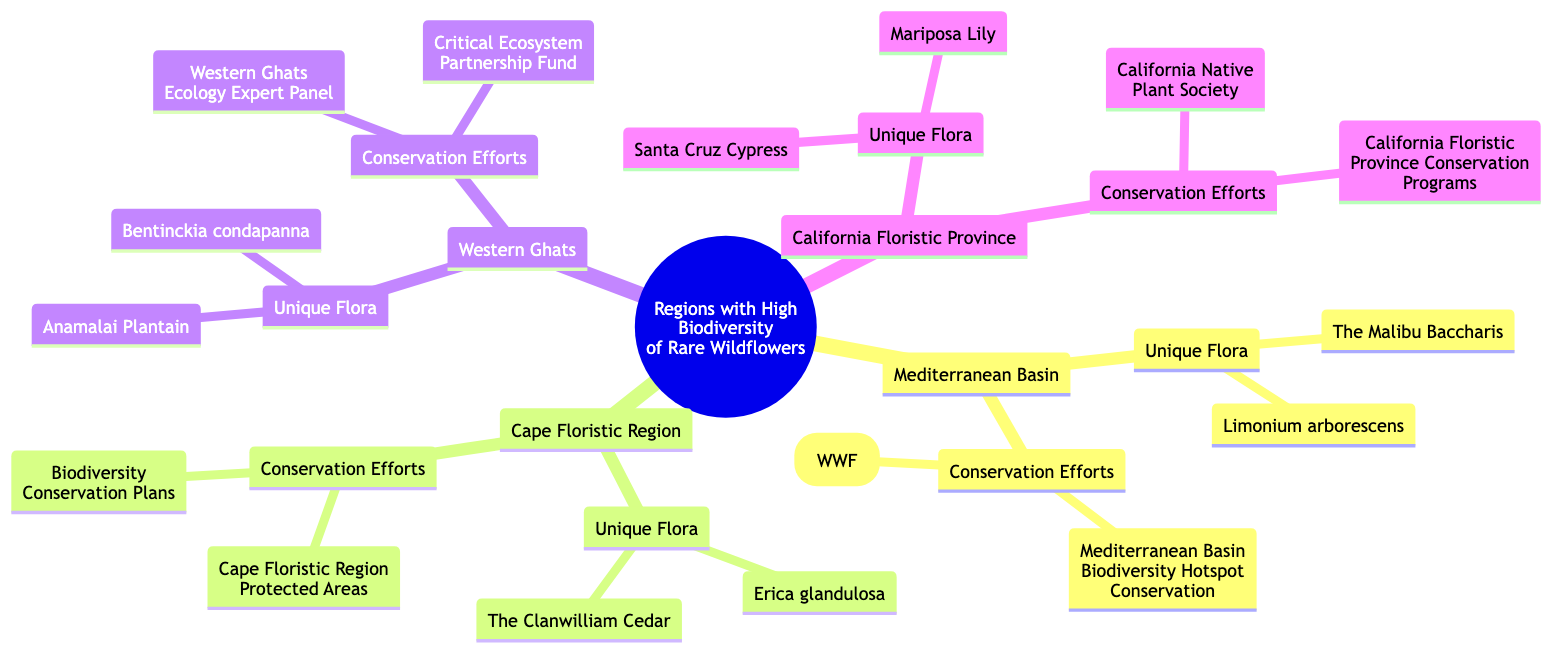What unique flora is found in the Mediterranean Basin? The Mediterranean Basin has two specific unique flora listed: The Malibu Baccharis and Limonium arborescens.
Answer: The Malibu Baccharis, Limonium arborescens How many unique flora are mentioned in the Cape Floristic Region? The Cape Floristic Region includes two unique flora: The Clanwilliam Cedar and Erica glandulosa, totaling two unique species.
Answer: 2 Which region has the Anamalai Plantain as part of its unique flora? The Anamalai Plantain is specifically listed under the unique flora of the Western Ghats.
Answer: Western Ghats What are the conservation efforts in the California Floristic Province? The conservation efforts listed for the California Floristic Province are the California Native Plant Society and California Floristic Province Conservation Programs.
Answer: California Native Plant Society, California Floristic Province Conservation Programs What is the total number of regions with high biodiversity of rare wildflowers in the diagram? There are four distinct regions represented in the diagram: Mediterranean Basin, Cape Floristic Region, Western Ghats, and California Floristic Province.
Answer: 4 Which region's conservation efforts include the Critical Ecosystem Partnership Fund? The Critical Ecosystem Partnership Fund is mentioned under the conservation efforts of the Western Ghats.
Answer: Western Ghats What is one unique flora found in the California Floristic Province? One unique flora listed for the California Floristic Province is the Mariposa Lily.
Answer: Mariposa Lily Which region has the highest biodiversity mentioned in the mind map? The mind map does not quantify the biodiversity; it lists regions with unique flora but does not specify which has the "highest." Therefore, the answer focuses on the regions presented without ranking.
Answer: Not specified What is the conservation program associated with the Mediterranean Basin? The Mediterranean Basin includes two conservation efforts: Mediterranean Basin Biodiversity Hotspot Conservation and Mediterranean Program (WWF).
Answer: Mediterranean Basin Biodiversity Hotspot Conservation, Mediterranean Program (WWF) 